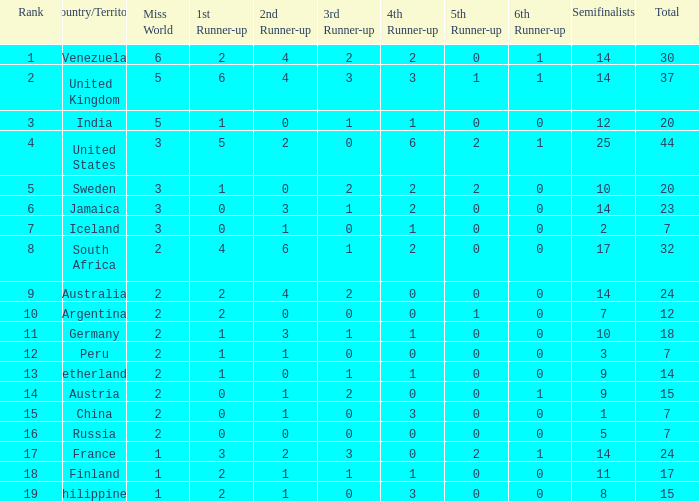What is venezuela's overall ranking? 30.0. 